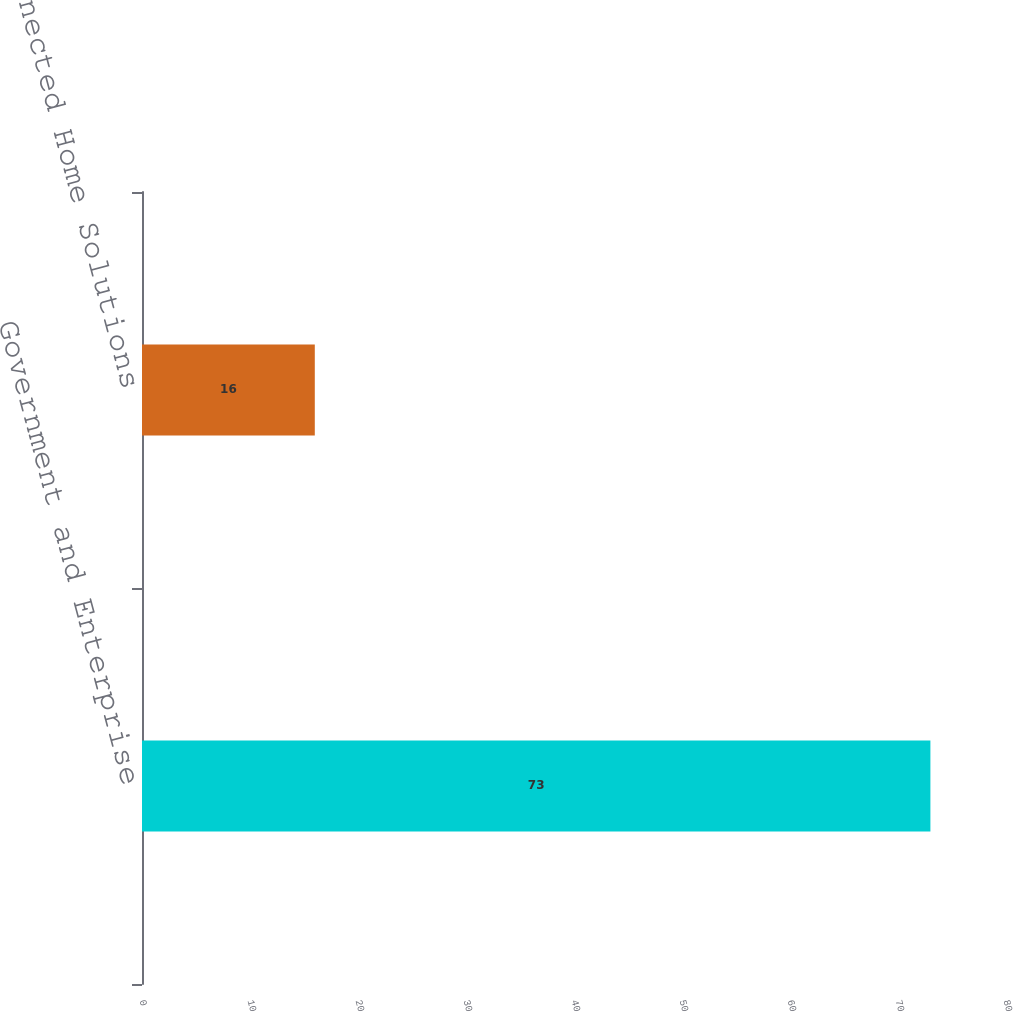<chart> <loc_0><loc_0><loc_500><loc_500><bar_chart><fcel>Government and Enterprise<fcel>Connected Home Solutions<nl><fcel>73<fcel>16<nl></chart> 